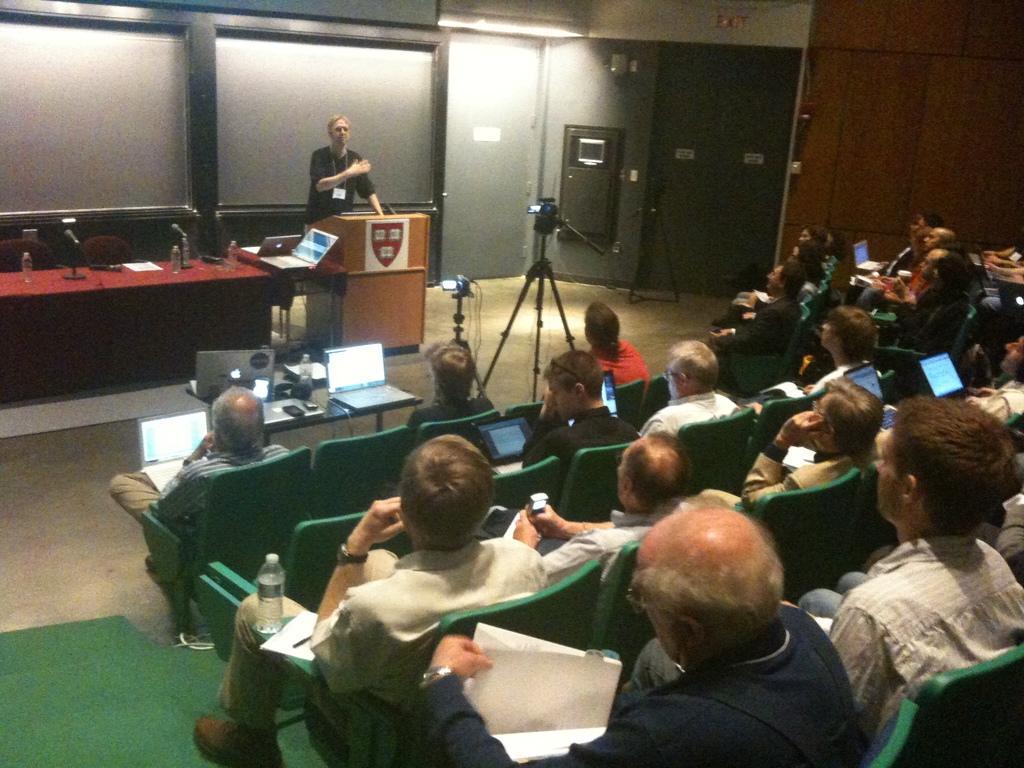Please provide a concise description of this image. In this image we can see many people sitting. Some are holding laptops. In the back we can see person standing. In front of him there is a podium. Also we can see a table. On the table we can see laptops, bottle and some other items. There are cameras on stands. In the back there are tables. On the tables there are mice, bottles, laptops and some other items. In the background we can see wall. 